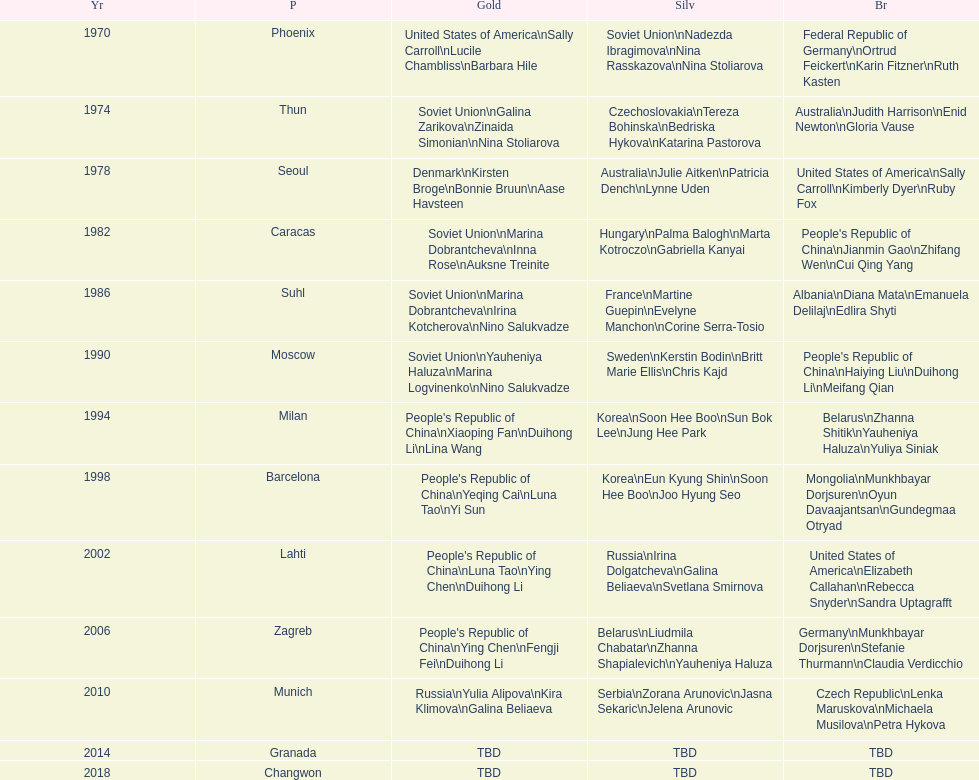What is the first place listed in this chart? Phoenix. 